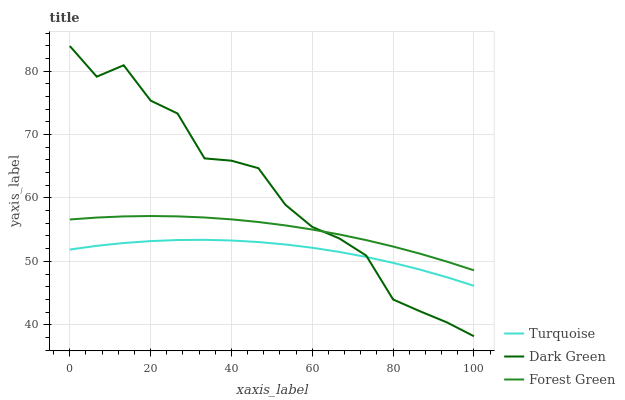Does Turquoise have the minimum area under the curve?
Answer yes or no. Yes. Does Dark Green have the maximum area under the curve?
Answer yes or no. Yes. Does Forest Green have the minimum area under the curve?
Answer yes or no. No. Does Forest Green have the maximum area under the curve?
Answer yes or no. No. Is Forest Green the smoothest?
Answer yes or no. Yes. Is Dark Green the roughest?
Answer yes or no. Yes. Is Dark Green the smoothest?
Answer yes or no. No. Is Forest Green the roughest?
Answer yes or no. No. Does Dark Green have the lowest value?
Answer yes or no. Yes. Does Forest Green have the lowest value?
Answer yes or no. No. Does Dark Green have the highest value?
Answer yes or no. Yes. Does Forest Green have the highest value?
Answer yes or no. No. Is Turquoise less than Forest Green?
Answer yes or no. Yes. Is Forest Green greater than Turquoise?
Answer yes or no. Yes. Does Forest Green intersect Dark Green?
Answer yes or no. Yes. Is Forest Green less than Dark Green?
Answer yes or no. No. Is Forest Green greater than Dark Green?
Answer yes or no. No. Does Turquoise intersect Forest Green?
Answer yes or no. No. 